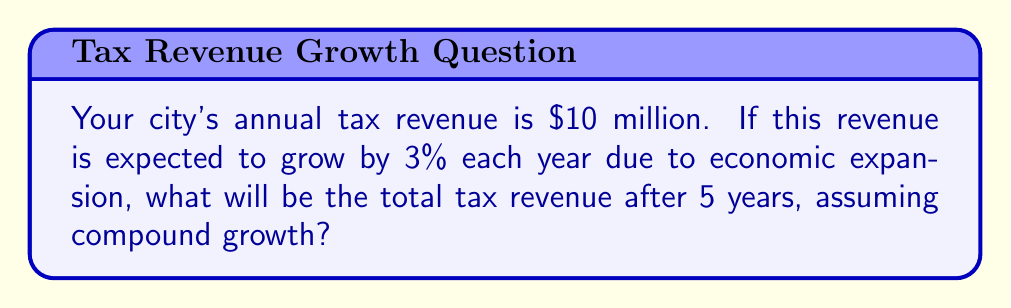Can you answer this question? To solve this problem, we'll use the compound interest formula:

$$A = P(1 + r)^n$$

Where:
$A$ = Final amount
$P$ = Principal (initial amount)
$r$ = Annual growth rate (as a decimal)
$n$ = Number of years

Given:
$P = \$10,000,000$
$r = 3\% = 0.03$
$n = 5$ years

Let's calculate step by step:

1) Substitute the values into the formula:
   $$A = 10,000,000(1 + 0.03)^5$$

2) Simplify the parentheses:
   $$A = 10,000,000(1.03)^5$$

3) Calculate the exponent:
   $$A = 10,000,000 \times 1.159274$$

4) Multiply:
   $$A = 11,592,740$$

Therefore, the total tax revenue after 5 years will be $11,592,740.
Answer: $11,592,740 